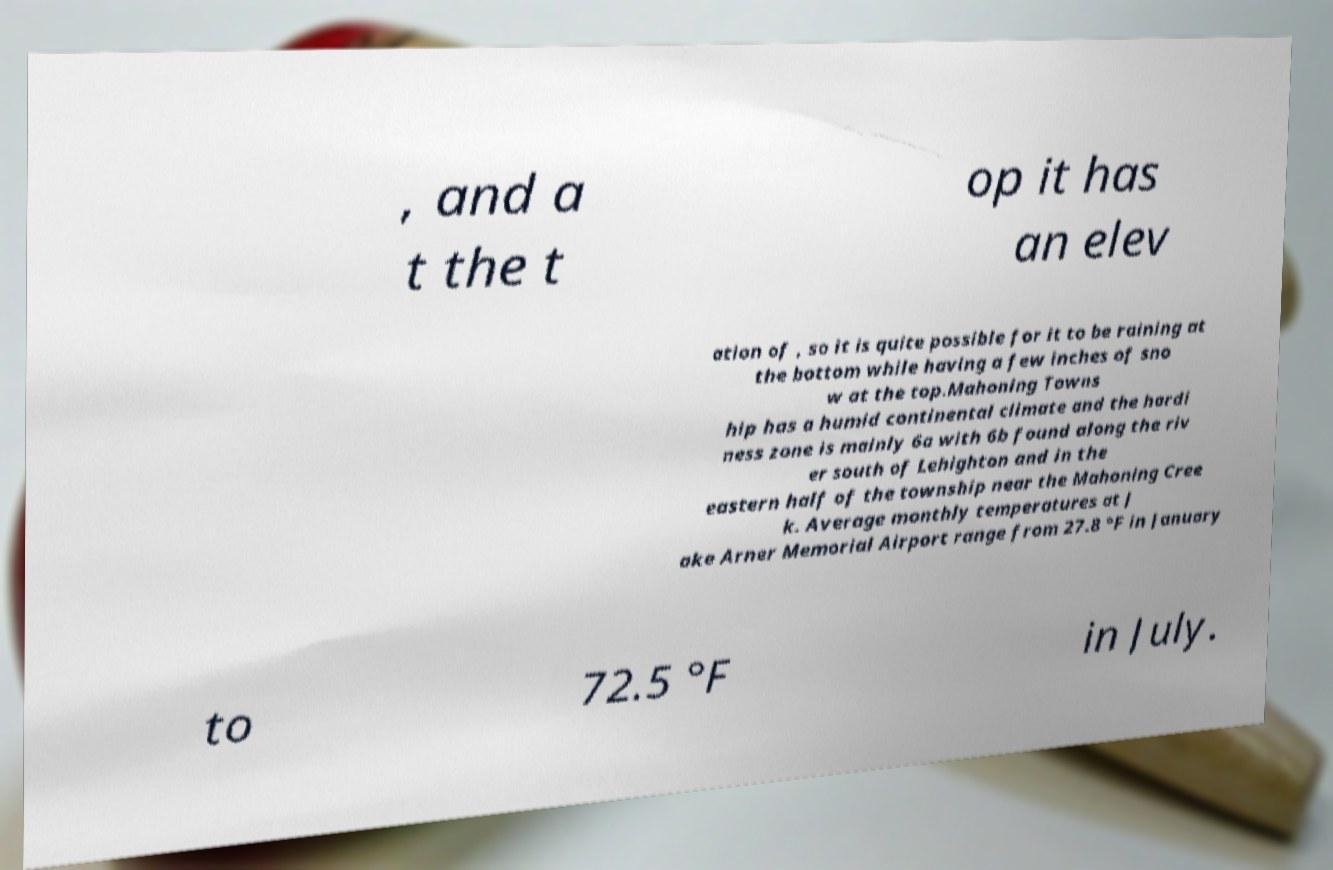What messages or text are displayed in this image? I need them in a readable, typed format. , and a t the t op it has an elev ation of , so it is quite possible for it to be raining at the bottom while having a few inches of sno w at the top.Mahoning Towns hip has a humid continental climate and the hardi ness zone is mainly 6a with 6b found along the riv er south of Lehighton and in the eastern half of the township near the Mahoning Cree k. Average monthly temperatures at J ake Arner Memorial Airport range from 27.8 °F in January to 72.5 °F in July. 